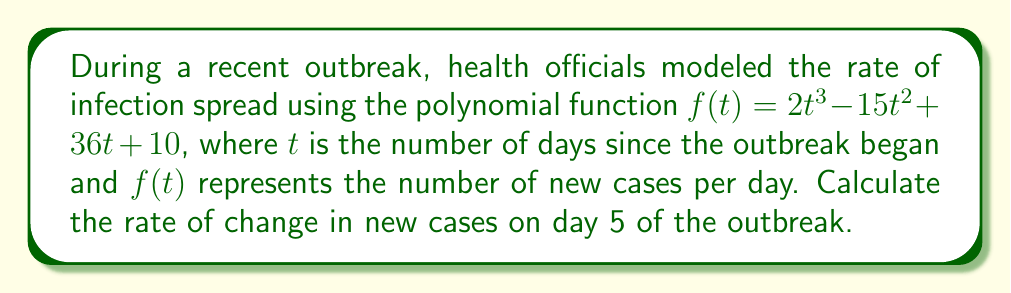Can you answer this question? To find the rate of change in new cases on day 5, we need to calculate the derivative of the function $f(t)$ and evaluate it at $t = 5$. Here's the step-by-step process:

1) First, let's find the derivative of $f(t)$:
   $f(t) = 2t^3 - 15t^2 + 36t + 10$
   $f'(t) = 6t^2 - 30t + 36$

   This derivative represents the rate of change of new cases with respect to time.

2) Now, we need to evaluate $f'(t)$ at $t = 5$:
   $f'(5) = 6(5)^2 - 30(5) + 36$

3) Let's calculate this step by step:
   $f'(5) = 6(25) - 150 + 36$
   $f'(5) = 150 - 150 + 36$
   $f'(5) = 36$

Therefore, on day 5 of the outbreak, the rate of change in new cases is 36 cases per day.
Answer: 36 cases per day 